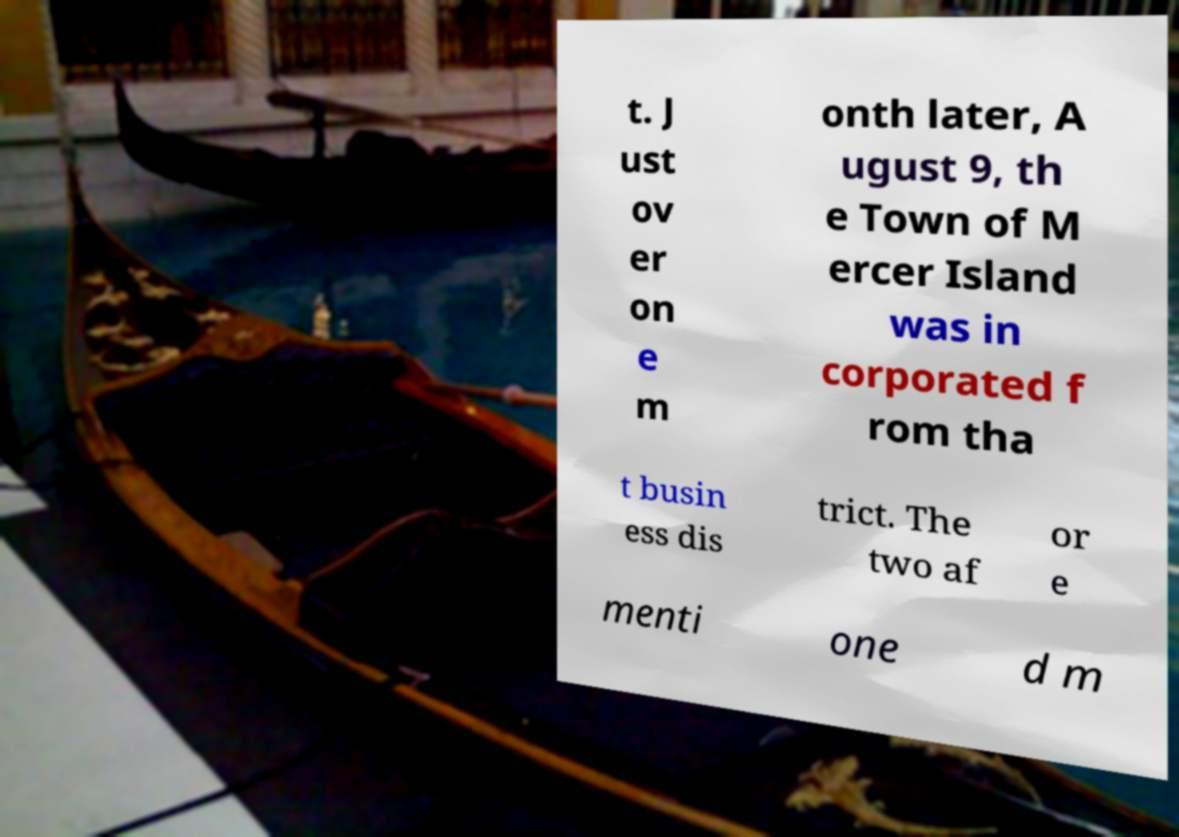Please read and relay the text visible in this image. What does it say? t. J ust ov er on e m onth later, A ugust 9, th e Town of M ercer Island was in corporated f rom tha t busin ess dis trict. The two af or e menti one d m 